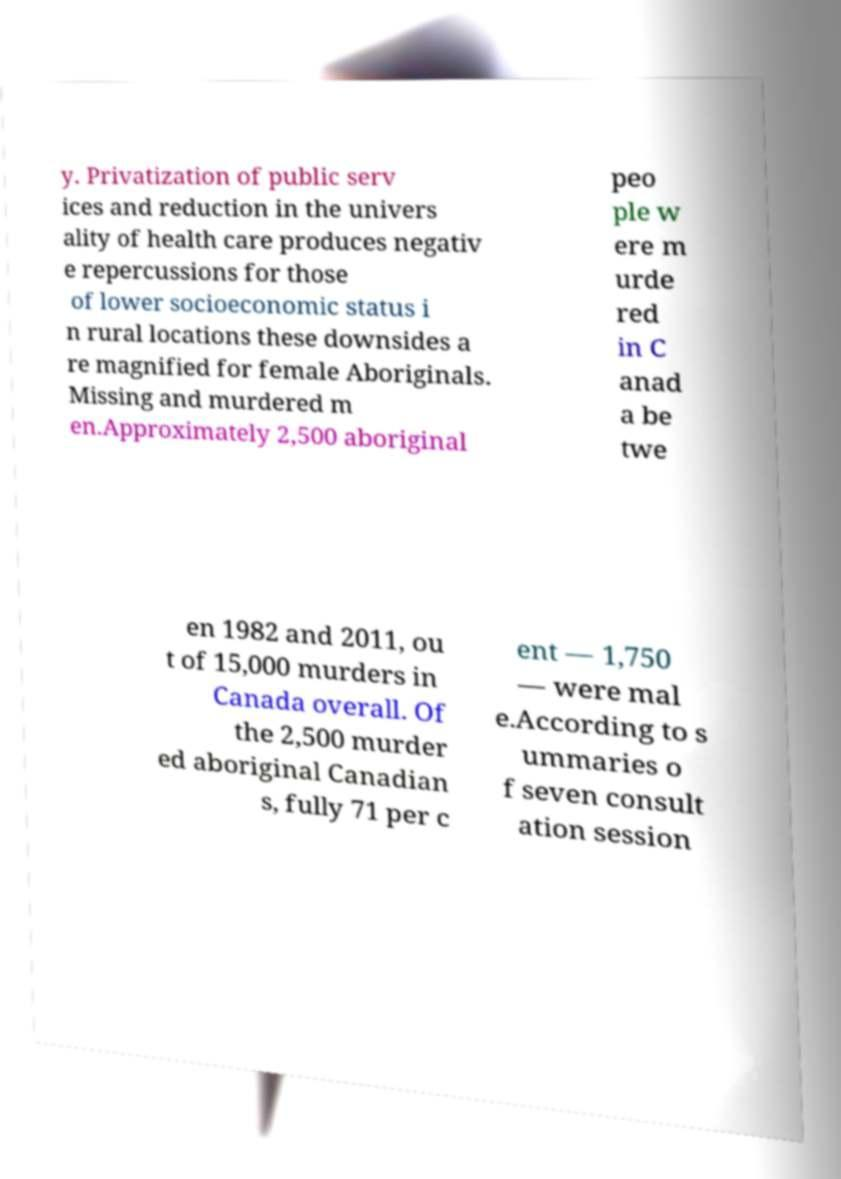Please read and relay the text visible in this image. What does it say? y. Privatization of public serv ices and reduction in the univers ality of health care produces negativ e repercussions for those of lower socioeconomic status i n rural locations these downsides a re magnified for female Aboriginals. Missing and murdered m en.Approximately 2,500 aboriginal peo ple w ere m urde red in C anad a be twe en 1982 and 2011, ou t of 15,000 murders in Canada overall. Of the 2,500 murder ed aboriginal Canadian s, fully 71 per c ent — 1,750 — were mal e.According to s ummaries o f seven consult ation session 